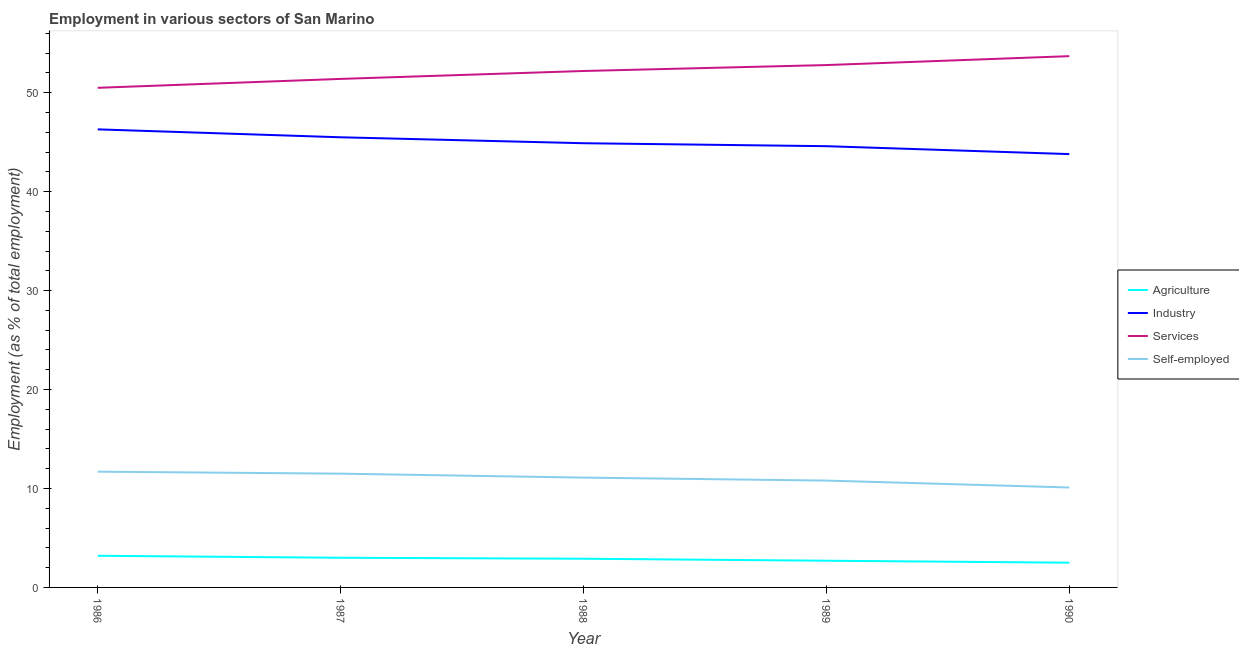How many different coloured lines are there?
Provide a short and direct response. 4. Is the number of lines equal to the number of legend labels?
Make the answer very short. Yes. What is the percentage of workers in industry in 1988?
Provide a succinct answer. 44.9. Across all years, what is the maximum percentage of workers in services?
Offer a very short reply. 53.7. Across all years, what is the minimum percentage of self employed workers?
Provide a succinct answer. 10.1. In which year was the percentage of self employed workers maximum?
Ensure brevity in your answer.  1986. In which year was the percentage of workers in agriculture minimum?
Offer a terse response. 1990. What is the total percentage of workers in industry in the graph?
Give a very brief answer. 225.1. What is the difference between the percentage of workers in agriculture in 1986 and that in 1988?
Your answer should be very brief. 0.3. What is the difference between the percentage of workers in services in 1989 and the percentage of self employed workers in 1986?
Your answer should be very brief. 41.1. What is the average percentage of workers in agriculture per year?
Offer a terse response. 2.86. In the year 1987, what is the difference between the percentage of workers in services and percentage of workers in agriculture?
Provide a succinct answer. 48.4. What is the ratio of the percentage of self employed workers in 1986 to that in 1989?
Provide a short and direct response. 1.08. Is the percentage of workers in services in 1986 less than that in 1988?
Ensure brevity in your answer.  Yes. Is the difference between the percentage of workers in industry in 1989 and 1990 greater than the difference between the percentage of workers in agriculture in 1989 and 1990?
Your answer should be compact. Yes. What is the difference between the highest and the second highest percentage of self employed workers?
Provide a short and direct response. 0.2. What is the difference between the highest and the lowest percentage of workers in agriculture?
Your answer should be very brief. 0.7. In how many years, is the percentage of workers in industry greater than the average percentage of workers in industry taken over all years?
Your answer should be very brief. 2. Is the sum of the percentage of workers in services in 1986 and 1987 greater than the maximum percentage of self employed workers across all years?
Keep it short and to the point. Yes. Does the percentage of workers in agriculture monotonically increase over the years?
Provide a succinct answer. No. Is the percentage of workers in industry strictly less than the percentage of workers in agriculture over the years?
Provide a succinct answer. No. How many lines are there?
Your answer should be very brief. 4. Where does the legend appear in the graph?
Keep it short and to the point. Center right. How are the legend labels stacked?
Your answer should be very brief. Vertical. What is the title of the graph?
Your answer should be compact. Employment in various sectors of San Marino. What is the label or title of the X-axis?
Offer a very short reply. Year. What is the label or title of the Y-axis?
Your response must be concise. Employment (as % of total employment). What is the Employment (as % of total employment) in Agriculture in 1986?
Ensure brevity in your answer.  3.2. What is the Employment (as % of total employment) in Industry in 1986?
Your answer should be compact. 46.3. What is the Employment (as % of total employment) of Services in 1986?
Ensure brevity in your answer.  50.5. What is the Employment (as % of total employment) of Self-employed in 1986?
Keep it short and to the point. 11.7. What is the Employment (as % of total employment) in Agriculture in 1987?
Ensure brevity in your answer.  3. What is the Employment (as % of total employment) of Industry in 1987?
Keep it short and to the point. 45.5. What is the Employment (as % of total employment) of Services in 1987?
Give a very brief answer. 51.4. What is the Employment (as % of total employment) in Agriculture in 1988?
Your response must be concise. 2.9. What is the Employment (as % of total employment) in Industry in 1988?
Offer a very short reply. 44.9. What is the Employment (as % of total employment) in Services in 1988?
Offer a very short reply. 52.2. What is the Employment (as % of total employment) in Self-employed in 1988?
Offer a terse response. 11.1. What is the Employment (as % of total employment) of Agriculture in 1989?
Your response must be concise. 2.7. What is the Employment (as % of total employment) in Industry in 1989?
Offer a very short reply. 44.6. What is the Employment (as % of total employment) in Services in 1989?
Your answer should be very brief. 52.8. What is the Employment (as % of total employment) of Self-employed in 1989?
Offer a very short reply. 10.8. What is the Employment (as % of total employment) of Industry in 1990?
Provide a short and direct response. 43.8. What is the Employment (as % of total employment) in Services in 1990?
Keep it short and to the point. 53.7. What is the Employment (as % of total employment) in Self-employed in 1990?
Keep it short and to the point. 10.1. Across all years, what is the maximum Employment (as % of total employment) of Agriculture?
Give a very brief answer. 3.2. Across all years, what is the maximum Employment (as % of total employment) in Industry?
Give a very brief answer. 46.3. Across all years, what is the maximum Employment (as % of total employment) of Services?
Make the answer very short. 53.7. Across all years, what is the maximum Employment (as % of total employment) of Self-employed?
Make the answer very short. 11.7. Across all years, what is the minimum Employment (as % of total employment) of Agriculture?
Provide a succinct answer. 2.5. Across all years, what is the minimum Employment (as % of total employment) in Industry?
Your answer should be compact. 43.8. Across all years, what is the minimum Employment (as % of total employment) of Services?
Keep it short and to the point. 50.5. Across all years, what is the minimum Employment (as % of total employment) of Self-employed?
Your response must be concise. 10.1. What is the total Employment (as % of total employment) of Industry in the graph?
Make the answer very short. 225.1. What is the total Employment (as % of total employment) of Services in the graph?
Keep it short and to the point. 260.6. What is the total Employment (as % of total employment) of Self-employed in the graph?
Give a very brief answer. 55.2. What is the difference between the Employment (as % of total employment) of Agriculture in 1986 and that in 1987?
Ensure brevity in your answer.  0.2. What is the difference between the Employment (as % of total employment) in Self-employed in 1986 and that in 1987?
Ensure brevity in your answer.  0.2. What is the difference between the Employment (as % of total employment) in Agriculture in 1986 and that in 1988?
Provide a succinct answer. 0.3. What is the difference between the Employment (as % of total employment) in Services in 1986 and that in 1988?
Provide a succinct answer. -1.7. What is the difference between the Employment (as % of total employment) of Self-employed in 1986 and that in 1988?
Provide a short and direct response. 0.6. What is the difference between the Employment (as % of total employment) in Agriculture in 1986 and that in 1989?
Ensure brevity in your answer.  0.5. What is the difference between the Employment (as % of total employment) in Industry in 1986 and that in 1989?
Give a very brief answer. 1.7. What is the difference between the Employment (as % of total employment) of Agriculture in 1986 and that in 1990?
Your response must be concise. 0.7. What is the difference between the Employment (as % of total employment) in Services in 1986 and that in 1990?
Your response must be concise. -3.2. What is the difference between the Employment (as % of total employment) in Self-employed in 1986 and that in 1990?
Your answer should be compact. 1.6. What is the difference between the Employment (as % of total employment) of Industry in 1987 and that in 1988?
Your answer should be compact. 0.6. What is the difference between the Employment (as % of total employment) in Self-employed in 1987 and that in 1988?
Give a very brief answer. 0.4. What is the difference between the Employment (as % of total employment) in Industry in 1987 and that in 1989?
Offer a very short reply. 0.9. What is the difference between the Employment (as % of total employment) in Self-employed in 1987 and that in 1989?
Your response must be concise. 0.7. What is the difference between the Employment (as % of total employment) in Industry in 1987 and that in 1990?
Your answer should be very brief. 1.7. What is the difference between the Employment (as % of total employment) in Services in 1987 and that in 1990?
Provide a succinct answer. -2.3. What is the difference between the Employment (as % of total employment) in Industry in 1988 and that in 1989?
Provide a succinct answer. 0.3. What is the difference between the Employment (as % of total employment) in Self-employed in 1988 and that in 1989?
Give a very brief answer. 0.3. What is the difference between the Employment (as % of total employment) of Agriculture in 1988 and that in 1990?
Ensure brevity in your answer.  0.4. What is the difference between the Employment (as % of total employment) in Services in 1988 and that in 1990?
Give a very brief answer. -1.5. What is the difference between the Employment (as % of total employment) of Agriculture in 1989 and that in 1990?
Ensure brevity in your answer.  0.2. What is the difference between the Employment (as % of total employment) in Services in 1989 and that in 1990?
Your answer should be very brief. -0.9. What is the difference between the Employment (as % of total employment) of Agriculture in 1986 and the Employment (as % of total employment) of Industry in 1987?
Offer a terse response. -42.3. What is the difference between the Employment (as % of total employment) of Agriculture in 1986 and the Employment (as % of total employment) of Services in 1987?
Your response must be concise. -48.2. What is the difference between the Employment (as % of total employment) in Industry in 1986 and the Employment (as % of total employment) in Self-employed in 1987?
Make the answer very short. 34.8. What is the difference between the Employment (as % of total employment) of Services in 1986 and the Employment (as % of total employment) of Self-employed in 1987?
Keep it short and to the point. 39. What is the difference between the Employment (as % of total employment) in Agriculture in 1986 and the Employment (as % of total employment) in Industry in 1988?
Make the answer very short. -41.7. What is the difference between the Employment (as % of total employment) in Agriculture in 1986 and the Employment (as % of total employment) in Services in 1988?
Your response must be concise. -49. What is the difference between the Employment (as % of total employment) of Industry in 1986 and the Employment (as % of total employment) of Services in 1988?
Your response must be concise. -5.9. What is the difference between the Employment (as % of total employment) in Industry in 1986 and the Employment (as % of total employment) in Self-employed in 1988?
Provide a short and direct response. 35.2. What is the difference between the Employment (as % of total employment) of Services in 1986 and the Employment (as % of total employment) of Self-employed in 1988?
Keep it short and to the point. 39.4. What is the difference between the Employment (as % of total employment) of Agriculture in 1986 and the Employment (as % of total employment) of Industry in 1989?
Make the answer very short. -41.4. What is the difference between the Employment (as % of total employment) of Agriculture in 1986 and the Employment (as % of total employment) of Services in 1989?
Make the answer very short. -49.6. What is the difference between the Employment (as % of total employment) of Industry in 1986 and the Employment (as % of total employment) of Self-employed in 1989?
Offer a very short reply. 35.5. What is the difference between the Employment (as % of total employment) of Services in 1986 and the Employment (as % of total employment) of Self-employed in 1989?
Offer a terse response. 39.7. What is the difference between the Employment (as % of total employment) in Agriculture in 1986 and the Employment (as % of total employment) in Industry in 1990?
Your answer should be very brief. -40.6. What is the difference between the Employment (as % of total employment) in Agriculture in 1986 and the Employment (as % of total employment) in Services in 1990?
Keep it short and to the point. -50.5. What is the difference between the Employment (as % of total employment) in Agriculture in 1986 and the Employment (as % of total employment) in Self-employed in 1990?
Ensure brevity in your answer.  -6.9. What is the difference between the Employment (as % of total employment) in Industry in 1986 and the Employment (as % of total employment) in Services in 1990?
Make the answer very short. -7.4. What is the difference between the Employment (as % of total employment) in Industry in 1986 and the Employment (as % of total employment) in Self-employed in 1990?
Ensure brevity in your answer.  36.2. What is the difference between the Employment (as % of total employment) in Services in 1986 and the Employment (as % of total employment) in Self-employed in 1990?
Ensure brevity in your answer.  40.4. What is the difference between the Employment (as % of total employment) of Agriculture in 1987 and the Employment (as % of total employment) of Industry in 1988?
Provide a succinct answer. -41.9. What is the difference between the Employment (as % of total employment) of Agriculture in 1987 and the Employment (as % of total employment) of Services in 1988?
Your answer should be compact. -49.2. What is the difference between the Employment (as % of total employment) in Agriculture in 1987 and the Employment (as % of total employment) in Self-employed in 1988?
Provide a succinct answer. -8.1. What is the difference between the Employment (as % of total employment) in Industry in 1987 and the Employment (as % of total employment) in Self-employed in 1988?
Your response must be concise. 34.4. What is the difference between the Employment (as % of total employment) of Services in 1987 and the Employment (as % of total employment) of Self-employed in 1988?
Give a very brief answer. 40.3. What is the difference between the Employment (as % of total employment) in Agriculture in 1987 and the Employment (as % of total employment) in Industry in 1989?
Your answer should be very brief. -41.6. What is the difference between the Employment (as % of total employment) of Agriculture in 1987 and the Employment (as % of total employment) of Services in 1989?
Make the answer very short. -49.8. What is the difference between the Employment (as % of total employment) of Agriculture in 1987 and the Employment (as % of total employment) of Self-employed in 1989?
Give a very brief answer. -7.8. What is the difference between the Employment (as % of total employment) in Industry in 1987 and the Employment (as % of total employment) in Self-employed in 1989?
Your answer should be very brief. 34.7. What is the difference between the Employment (as % of total employment) in Services in 1987 and the Employment (as % of total employment) in Self-employed in 1989?
Offer a terse response. 40.6. What is the difference between the Employment (as % of total employment) of Agriculture in 1987 and the Employment (as % of total employment) of Industry in 1990?
Ensure brevity in your answer.  -40.8. What is the difference between the Employment (as % of total employment) of Agriculture in 1987 and the Employment (as % of total employment) of Services in 1990?
Provide a succinct answer. -50.7. What is the difference between the Employment (as % of total employment) in Agriculture in 1987 and the Employment (as % of total employment) in Self-employed in 1990?
Your answer should be very brief. -7.1. What is the difference between the Employment (as % of total employment) of Industry in 1987 and the Employment (as % of total employment) of Services in 1990?
Provide a short and direct response. -8.2. What is the difference between the Employment (as % of total employment) of Industry in 1987 and the Employment (as % of total employment) of Self-employed in 1990?
Offer a terse response. 35.4. What is the difference between the Employment (as % of total employment) in Services in 1987 and the Employment (as % of total employment) in Self-employed in 1990?
Your answer should be very brief. 41.3. What is the difference between the Employment (as % of total employment) in Agriculture in 1988 and the Employment (as % of total employment) in Industry in 1989?
Offer a terse response. -41.7. What is the difference between the Employment (as % of total employment) in Agriculture in 1988 and the Employment (as % of total employment) in Services in 1989?
Give a very brief answer. -49.9. What is the difference between the Employment (as % of total employment) of Agriculture in 1988 and the Employment (as % of total employment) of Self-employed in 1989?
Offer a terse response. -7.9. What is the difference between the Employment (as % of total employment) of Industry in 1988 and the Employment (as % of total employment) of Self-employed in 1989?
Keep it short and to the point. 34.1. What is the difference between the Employment (as % of total employment) in Services in 1988 and the Employment (as % of total employment) in Self-employed in 1989?
Make the answer very short. 41.4. What is the difference between the Employment (as % of total employment) in Agriculture in 1988 and the Employment (as % of total employment) in Industry in 1990?
Provide a succinct answer. -40.9. What is the difference between the Employment (as % of total employment) in Agriculture in 1988 and the Employment (as % of total employment) in Services in 1990?
Offer a very short reply. -50.8. What is the difference between the Employment (as % of total employment) of Agriculture in 1988 and the Employment (as % of total employment) of Self-employed in 1990?
Provide a succinct answer. -7.2. What is the difference between the Employment (as % of total employment) in Industry in 1988 and the Employment (as % of total employment) in Self-employed in 1990?
Ensure brevity in your answer.  34.8. What is the difference between the Employment (as % of total employment) in Services in 1988 and the Employment (as % of total employment) in Self-employed in 1990?
Your answer should be very brief. 42.1. What is the difference between the Employment (as % of total employment) in Agriculture in 1989 and the Employment (as % of total employment) in Industry in 1990?
Your response must be concise. -41.1. What is the difference between the Employment (as % of total employment) in Agriculture in 1989 and the Employment (as % of total employment) in Services in 1990?
Ensure brevity in your answer.  -51. What is the difference between the Employment (as % of total employment) in Industry in 1989 and the Employment (as % of total employment) in Services in 1990?
Your answer should be compact. -9.1. What is the difference between the Employment (as % of total employment) in Industry in 1989 and the Employment (as % of total employment) in Self-employed in 1990?
Give a very brief answer. 34.5. What is the difference between the Employment (as % of total employment) in Services in 1989 and the Employment (as % of total employment) in Self-employed in 1990?
Your answer should be very brief. 42.7. What is the average Employment (as % of total employment) of Agriculture per year?
Your response must be concise. 2.86. What is the average Employment (as % of total employment) of Industry per year?
Make the answer very short. 45.02. What is the average Employment (as % of total employment) in Services per year?
Provide a succinct answer. 52.12. What is the average Employment (as % of total employment) in Self-employed per year?
Provide a succinct answer. 11.04. In the year 1986, what is the difference between the Employment (as % of total employment) of Agriculture and Employment (as % of total employment) of Industry?
Provide a succinct answer. -43.1. In the year 1986, what is the difference between the Employment (as % of total employment) in Agriculture and Employment (as % of total employment) in Services?
Give a very brief answer. -47.3. In the year 1986, what is the difference between the Employment (as % of total employment) in Agriculture and Employment (as % of total employment) in Self-employed?
Make the answer very short. -8.5. In the year 1986, what is the difference between the Employment (as % of total employment) of Industry and Employment (as % of total employment) of Self-employed?
Your response must be concise. 34.6. In the year 1986, what is the difference between the Employment (as % of total employment) in Services and Employment (as % of total employment) in Self-employed?
Your answer should be very brief. 38.8. In the year 1987, what is the difference between the Employment (as % of total employment) in Agriculture and Employment (as % of total employment) in Industry?
Your response must be concise. -42.5. In the year 1987, what is the difference between the Employment (as % of total employment) in Agriculture and Employment (as % of total employment) in Services?
Your response must be concise. -48.4. In the year 1987, what is the difference between the Employment (as % of total employment) of Services and Employment (as % of total employment) of Self-employed?
Provide a short and direct response. 39.9. In the year 1988, what is the difference between the Employment (as % of total employment) in Agriculture and Employment (as % of total employment) in Industry?
Offer a terse response. -42. In the year 1988, what is the difference between the Employment (as % of total employment) of Agriculture and Employment (as % of total employment) of Services?
Make the answer very short. -49.3. In the year 1988, what is the difference between the Employment (as % of total employment) of Agriculture and Employment (as % of total employment) of Self-employed?
Keep it short and to the point. -8.2. In the year 1988, what is the difference between the Employment (as % of total employment) of Industry and Employment (as % of total employment) of Services?
Offer a terse response. -7.3. In the year 1988, what is the difference between the Employment (as % of total employment) in Industry and Employment (as % of total employment) in Self-employed?
Provide a short and direct response. 33.8. In the year 1988, what is the difference between the Employment (as % of total employment) of Services and Employment (as % of total employment) of Self-employed?
Your answer should be very brief. 41.1. In the year 1989, what is the difference between the Employment (as % of total employment) of Agriculture and Employment (as % of total employment) of Industry?
Offer a very short reply. -41.9. In the year 1989, what is the difference between the Employment (as % of total employment) of Agriculture and Employment (as % of total employment) of Services?
Ensure brevity in your answer.  -50.1. In the year 1989, what is the difference between the Employment (as % of total employment) in Industry and Employment (as % of total employment) in Self-employed?
Keep it short and to the point. 33.8. In the year 1989, what is the difference between the Employment (as % of total employment) of Services and Employment (as % of total employment) of Self-employed?
Ensure brevity in your answer.  42. In the year 1990, what is the difference between the Employment (as % of total employment) of Agriculture and Employment (as % of total employment) of Industry?
Offer a terse response. -41.3. In the year 1990, what is the difference between the Employment (as % of total employment) of Agriculture and Employment (as % of total employment) of Services?
Provide a short and direct response. -51.2. In the year 1990, what is the difference between the Employment (as % of total employment) in Industry and Employment (as % of total employment) in Self-employed?
Provide a succinct answer. 33.7. In the year 1990, what is the difference between the Employment (as % of total employment) of Services and Employment (as % of total employment) of Self-employed?
Provide a short and direct response. 43.6. What is the ratio of the Employment (as % of total employment) of Agriculture in 1986 to that in 1987?
Provide a short and direct response. 1.07. What is the ratio of the Employment (as % of total employment) in Industry in 1986 to that in 1987?
Your answer should be compact. 1.02. What is the ratio of the Employment (as % of total employment) in Services in 1986 to that in 1987?
Provide a short and direct response. 0.98. What is the ratio of the Employment (as % of total employment) in Self-employed in 1986 to that in 1987?
Give a very brief answer. 1.02. What is the ratio of the Employment (as % of total employment) of Agriculture in 1986 to that in 1988?
Your response must be concise. 1.1. What is the ratio of the Employment (as % of total employment) in Industry in 1986 to that in 1988?
Ensure brevity in your answer.  1.03. What is the ratio of the Employment (as % of total employment) in Services in 1986 to that in 1988?
Offer a terse response. 0.97. What is the ratio of the Employment (as % of total employment) of Self-employed in 1986 to that in 1988?
Offer a terse response. 1.05. What is the ratio of the Employment (as % of total employment) in Agriculture in 1986 to that in 1989?
Make the answer very short. 1.19. What is the ratio of the Employment (as % of total employment) of Industry in 1986 to that in 1989?
Your response must be concise. 1.04. What is the ratio of the Employment (as % of total employment) of Services in 1986 to that in 1989?
Offer a terse response. 0.96. What is the ratio of the Employment (as % of total employment) in Self-employed in 1986 to that in 1989?
Keep it short and to the point. 1.08. What is the ratio of the Employment (as % of total employment) in Agriculture in 1986 to that in 1990?
Your answer should be compact. 1.28. What is the ratio of the Employment (as % of total employment) in Industry in 1986 to that in 1990?
Offer a very short reply. 1.06. What is the ratio of the Employment (as % of total employment) in Services in 1986 to that in 1990?
Your response must be concise. 0.94. What is the ratio of the Employment (as % of total employment) of Self-employed in 1986 to that in 1990?
Provide a succinct answer. 1.16. What is the ratio of the Employment (as % of total employment) in Agriculture in 1987 to that in 1988?
Offer a terse response. 1.03. What is the ratio of the Employment (as % of total employment) in Industry in 1987 to that in 1988?
Provide a short and direct response. 1.01. What is the ratio of the Employment (as % of total employment) of Services in 1987 to that in 1988?
Provide a succinct answer. 0.98. What is the ratio of the Employment (as % of total employment) in Self-employed in 1987 to that in 1988?
Ensure brevity in your answer.  1.04. What is the ratio of the Employment (as % of total employment) of Agriculture in 1987 to that in 1989?
Make the answer very short. 1.11. What is the ratio of the Employment (as % of total employment) of Industry in 1987 to that in 1989?
Offer a terse response. 1.02. What is the ratio of the Employment (as % of total employment) in Services in 1987 to that in 1989?
Make the answer very short. 0.97. What is the ratio of the Employment (as % of total employment) of Self-employed in 1987 to that in 1989?
Make the answer very short. 1.06. What is the ratio of the Employment (as % of total employment) in Industry in 1987 to that in 1990?
Your answer should be very brief. 1.04. What is the ratio of the Employment (as % of total employment) of Services in 1987 to that in 1990?
Your answer should be very brief. 0.96. What is the ratio of the Employment (as % of total employment) in Self-employed in 1987 to that in 1990?
Make the answer very short. 1.14. What is the ratio of the Employment (as % of total employment) in Agriculture in 1988 to that in 1989?
Make the answer very short. 1.07. What is the ratio of the Employment (as % of total employment) of Services in 1988 to that in 1989?
Your answer should be very brief. 0.99. What is the ratio of the Employment (as % of total employment) in Self-employed in 1988 to that in 1989?
Make the answer very short. 1.03. What is the ratio of the Employment (as % of total employment) of Agriculture in 1988 to that in 1990?
Your answer should be compact. 1.16. What is the ratio of the Employment (as % of total employment) of Industry in 1988 to that in 1990?
Make the answer very short. 1.03. What is the ratio of the Employment (as % of total employment) in Services in 1988 to that in 1990?
Provide a short and direct response. 0.97. What is the ratio of the Employment (as % of total employment) in Self-employed in 1988 to that in 1990?
Make the answer very short. 1.1. What is the ratio of the Employment (as % of total employment) of Industry in 1989 to that in 1990?
Give a very brief answer. 1.02. What is the ratio of the Employment (as % of total employment) of Services in 1989 to that in 1990?
Keep it short and to the point. 0.98. What is the ratio of the Employment (as % of total employment) in Self-employed in 1989 to that in 1990?
Keep it short and to the point. 1.07. What is the difference between the highest and the second highest Employment (as % of total employment) in Agriculture?
Keep it short and to the point. 0.2. What is the difference between the highest and the second highest Employment (as % of total employment) of Services?
Ensure brevity in your answer.  0.9. What is the difference between the highest and the lowest Employment (as % of total employment) of Agriculture?
Give a very brief answer. 0.7. What is the difference between the highest and the lowest Employment (as % of total employment) in Services?
Offer a terse response. 3.2. 